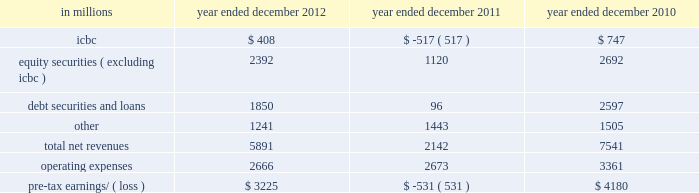Management 2019s discussion and analysis net revenues in equities were $ 8.26 billion for 2011 , 2% ( 2 % ) higher than 2010 .
During 2011 , average volatility levels increased and equity prices in europe and asia declined significantly , particularly during the third quarter .
The increase in net revenues reflected higher commissions and fees , primarily due to higher market volumes , particularly during the third quarter of 2011 .
In addition , net revenues in securities services increased compared with 2010 , reflecting the impact of higher average customer balances .
Equities client execution net revenues were lower than 2010 , primarily reflecting significantly lower net revenues in shares .
The net gain attributable to the impact of changes in our own credit spreads on borrowings for which the fair value option was elected was $ 596 million ( $ 399 million and $ 197 million related to fixed income , currency and commodities client execution and equities client execution , respectively ) for 2011 , compared with a net gain of $ 198 million ( $ 188 million and $ 10 million related to fixed income , currency and commodities client execution and equities client execution , respectively ) for 2010 .
Institutional client services operated in an environment generally characterized by increased concerns regarding the weakened state of global economies , including heightened european sovereign debt risk , and its impact on the european banking system and global financial institutions .
These conditions also impacted expectations for economic prospects in the united states and were reflected in equity and debt markets more broadly .
In addition , the downgrade in credit ratings of the u.s .
Government and federal agencies and many financial institutions during the second half of 2011 contributed to further uncertainty in the markets .
These concerns , as well as other broad market concerns , such as uncertainty over financial regulatory reform , continued to have a negative impact on our net revenues during 2011 .
Operating expenses were $ 12.84 billion for 2011 , 14% ( 14 % ) lower than 2010 , due to decreased compensation and benefits expenses , primarily resulting from lower net revenues , lower net provisions for litigation and regulatory proceedings ( 2010 included $ 550 million related to a settlement with the sec ) , the impact of the u.k .
Bank payroll tax during 2010 , as well as an impairment of our nyse dmm rights of $ 305 million during 2010 .
These decreases were partially offset by higher brokerage , clearing , exchange and distribution fees , principally reflecting higher transaction volumes in equities .
Pre-tax earnings were $ 4.44 billion in 2011 , 35% ( 35 % ) lower than 2010 .
Investing & lending investing & lending includes our investing activities and the origination of loans to provide financing to clients .
These investments and loans are typically longer-term in nature .
We make investments , directly and indirectly through funds that we manage , in debt securities and loans , public and private equity securities , real estate , consolidated investment entities and power generation facilities .
The table below presents the operating results of our investing & lending segment. .
2012 versus 2011 .
Net revenues in investing & lending were $ 5.89 billion and $ 2.14 billion for 2012 and 2011 , respectively .
During 2012 , investing & lending net revenues were positively impacted by tighter credit spreads and an increase in global equity prices .
Results for 2012 included a gain of $ 408 million from our investment in the ordinary shares of icbc , net gains of $ 2.39 billion from other investments in equities , primarily in private equities , net gains and net interest income of $ 1.85 billion from debt securities and loans , and other net revenues of $ 1.24 billion , principally related to our consolidated investment entities .
If equity markets decline or credit spreads widen , net revenues in investing & lending would likely be negatively impacted .
Operating expenses were $ 2.67 billion for 2012 , essentially unchanged compared with 2011 .
Pre-tax earnings were $ 3.23 billion in 2012 , compared with a pre-tax loss of $ 531 million in 2011 .
Goldman sachs 2012 annual report 55 .
What percentage of total net revenues in 2012 where due to equity securities ( excluding icbc ) revenues? 
Computations: (2392 / 5891)
Answer: 0.40604. 